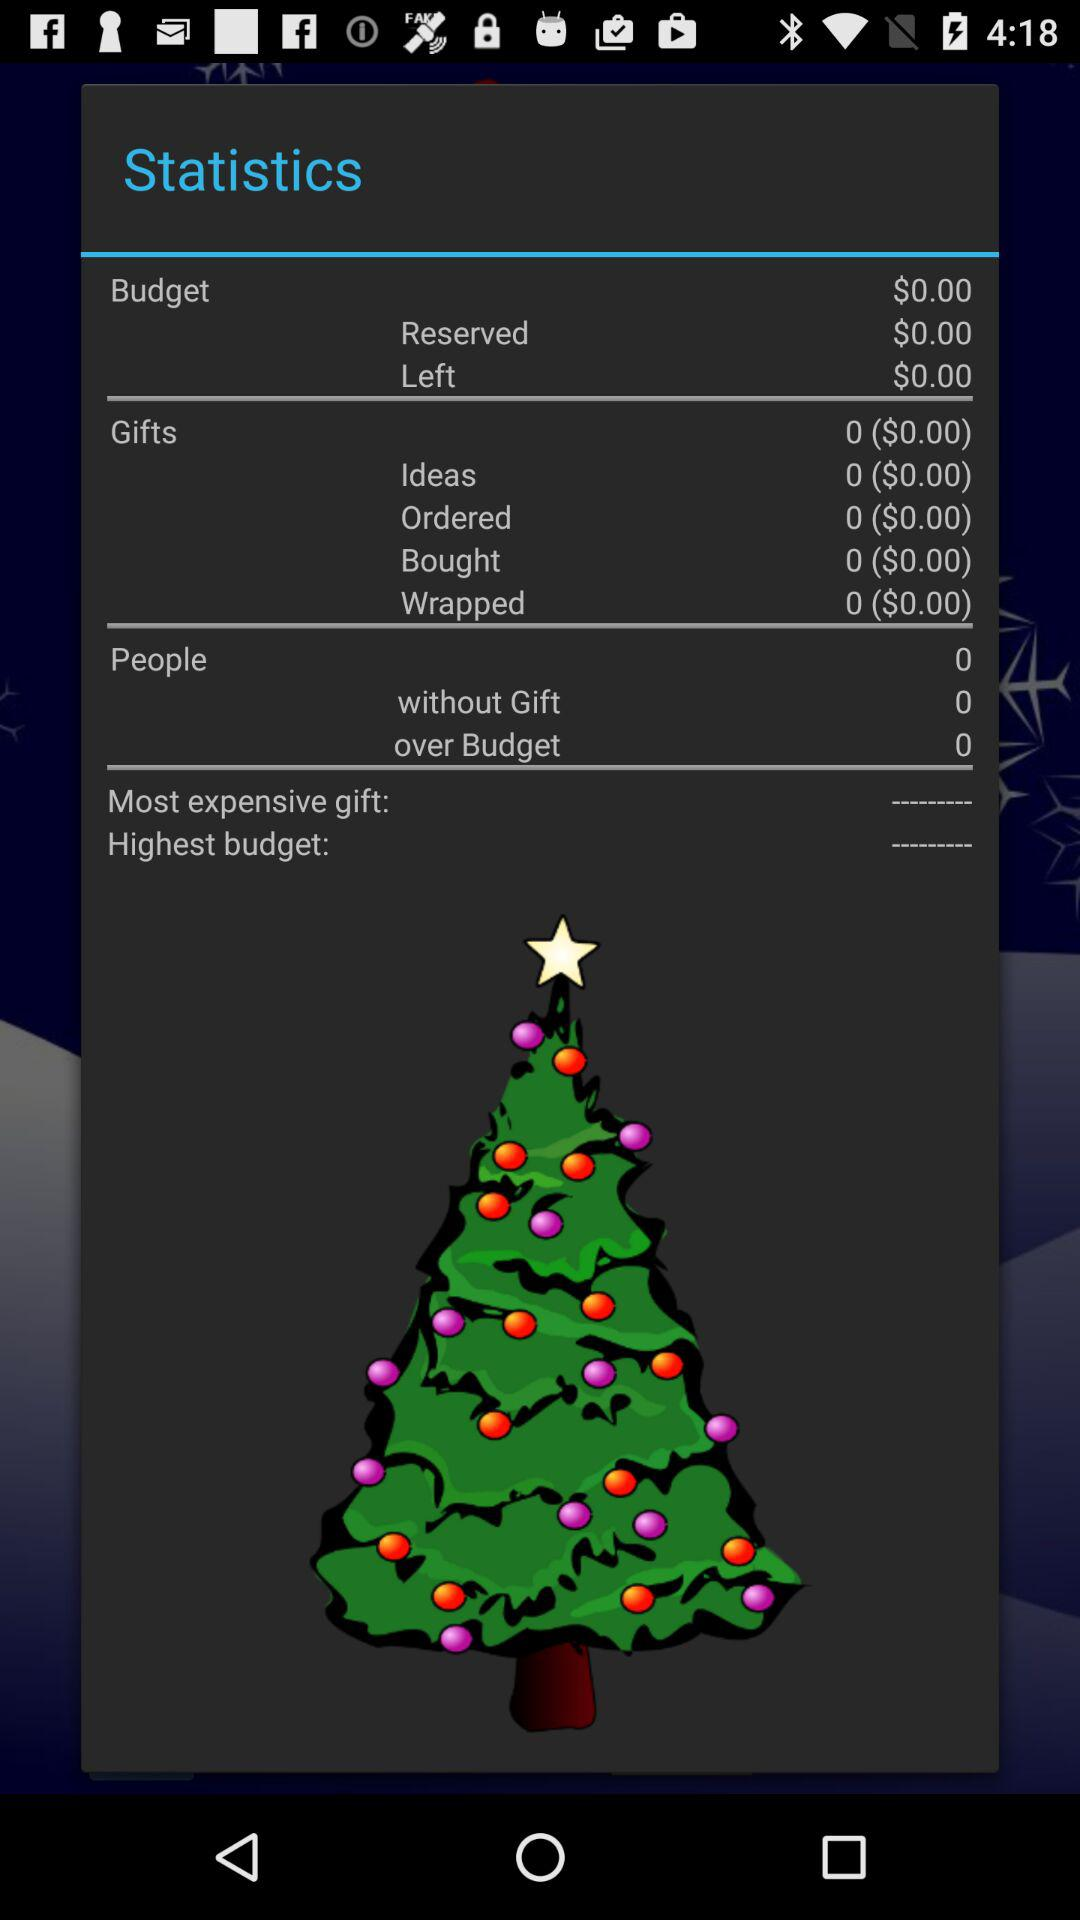What is the statistics of the most expensive gift?
When the provided information is insufficient, respond with <no answer>. <no answer> 